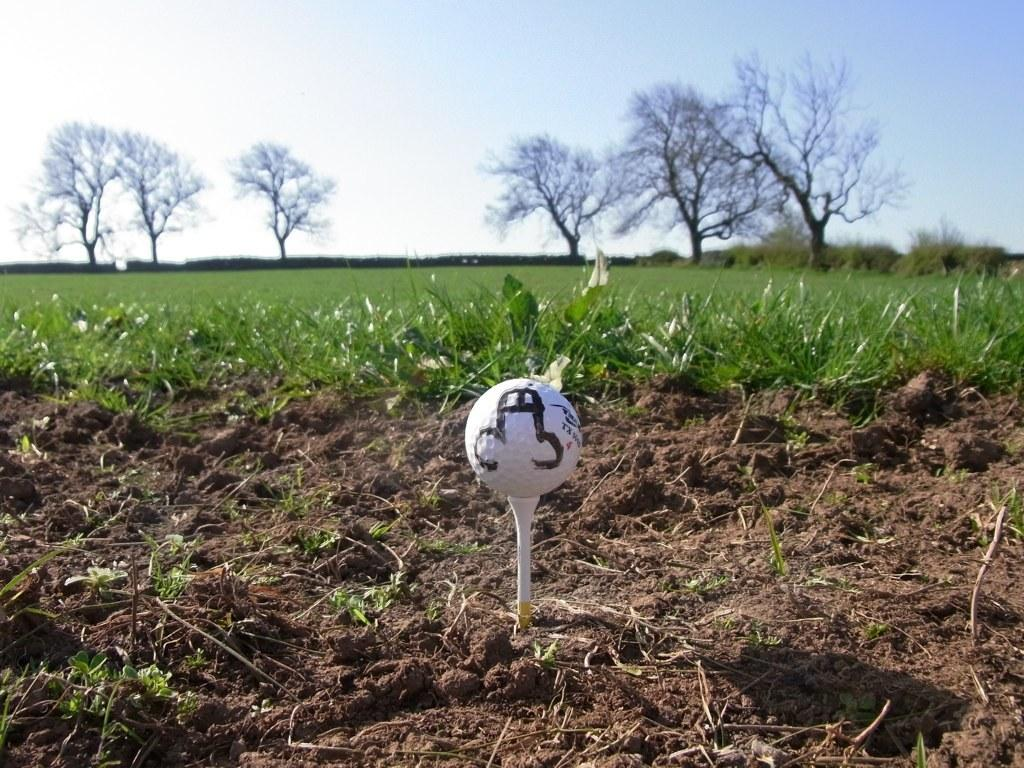What can be seen at the top of the image? The sky is visible towards the top of the image. What type of vegetation is present in the image? There are trees and grass in the image. What is present at the bottom of the image? Soil is present towards the bottom of the image. What object has a ball on it in the image? There is a ball on an object in the image. What type of noise can be heard coming from the trees in the image? There is no indication of any noise in the image, as it only shows visual elements like the sky, trees, grass, soil, and a ball on an object. 